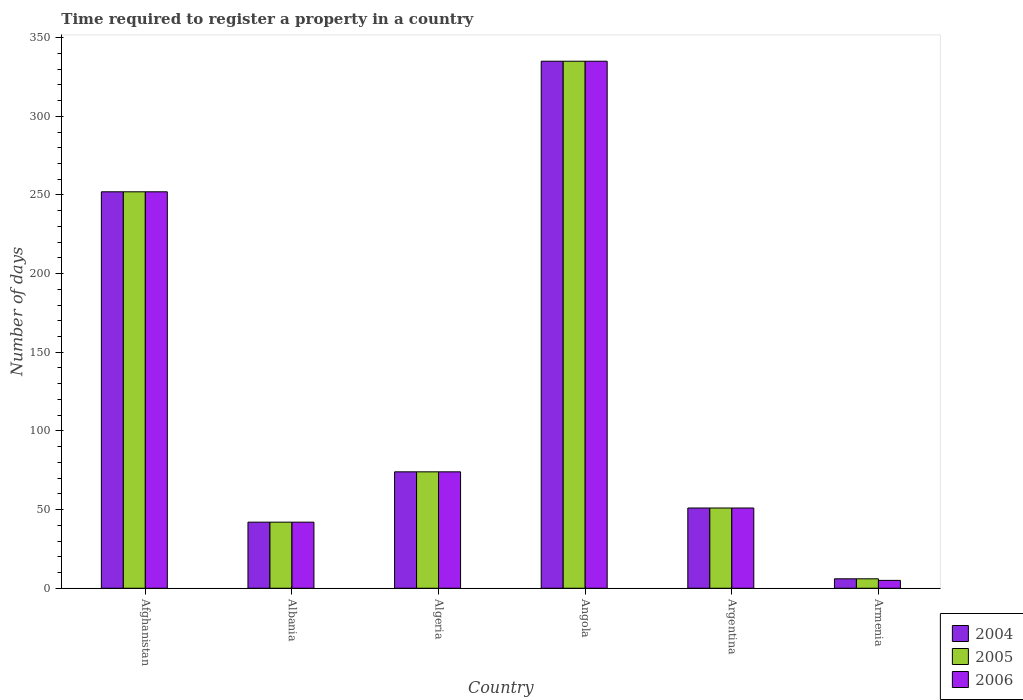Are the number of bars on each tick of the X-axis equal?
Provide a succinct answer. Yes. What is the label of the 3rd group of bars from the left?
Your response must be concise. Algeria. In how many cases, is the number of bars for a given country not equal to the number of legend labels?
Ensure brevity in your answer.  0. What is the number of days required to register a property in 2004 in Armenia?
Your answer should be compact. 6. Across all countries, what is the maximum number of days required to register a property in 2005?
Offer a terse response. 335. In which country was the number of days required to register a property in 2005 maximum?
Make the answer very short. Angola. In which country was the number of days required to register a property in 2004 minimum?
Your answer should be compact. Armenia. What is the total number of days required to register a property in 2006 in the graph?
Make the answer very short. 759. What is the difference between the number of days required to register a property in 2006 in Algeria and that in Angola?
Provide a succinct answer. -261. What is the difference between the number of days required to register a property in 2006 in Albania and the number of days required to register a property in 2004 in Angola?
Make the answer very short. -293. What is the average number of days required to register a property in 2006 per country?
Provide a succinct answer. 126.5. What is the difference between the number of days required to register a property of/in 2004 and number of days required to register a property of/in 2005 in Afghanistan?
Offer a terse response. 0. What is the ratio of the number of days required to register a property in 2004 in Angola to that in Argentina?
Keep it short and to the point. 6.57. Is the number of days required to register a property in 2006 in Afghanistan less than that in Albania?
Provide a succinct answer. No. Is the difference between the number of days required to register a property in 2004 in Afghanistan and Argentina greater than the difference between the number of days required to register a property in 2005 in Afghanistan and Argentina?
Keep it short and to the point. No. What is the difference between the highest and the second highest number of days required to register a property in 2006?
Provide a short and direct response. -178. What is the difference between the highest and the lowest number of days required to register a property in 2006?
Provide a succinct answer. 330. In how many countries, is the number of days required to register a property in 2006 greater than the average number of days required to register a property in 2006 taken over all countries?
Provide a short and direct response. 2. Is the sum of the number of days required to register a property in 2004 in Albania and Angola greater than the maximum number of days required to register a property in 2006 across all countries?
Make the answer very short. Yes. Is it the case that in every country, the sum of the number of days required to register a property in 2005 and number of days required to register a property in 2004 is greater than the number of days required to register a property in 2006?
Offer a very short reply. Yes. Are all the bars in the graph horizontal?
Your answer should be compact. No. How many countries are there in the graph?
Keep it short and to the point. 6. What is the difference between two consecutive major ticks on the Y-axis?
Your response must be concise. 50. Does the graph contain any zero values?
Provide a short and direct response. No. What is the title of the graph?
Provide a short and direct response. Time required to register a property in a country. Does "2008" appear as one of the legend labels in the graph?
Your answer should be very brief. No. What is the label or title of the Y-axis?
Offer a very short reply. Number of days. What is the Number of days in 2004 in Afghanistan?
Give a very brief answer. 252. What is the Number of days in 2005 in Afghanistan?
Make the answer very short. 252. What is the Number of days of 2006 in Afghanistan?
Make the answer very short. 252. What is the Number of days in 2005 in Albania?
Provide a succinct answer. 42. What is the Number of days in 2005 in Algeria?
Your response must be concise. 74. What is the Number of days in 2004 in Angola?
Offer a very short reply. 335. What is the Number of days of 2005 in Angola?
Your answer should be compact. 335. What is the Number of days in 2006 in Angola?
Give a very brief answer. 335. What is the Number of days in 2004 in Argentina?
Your response must be concise. 51. What is the Number of days in 2006 in Argentina?
Offer a very short reply. 51. What is the Number of days in 2004 in Armenia?
Offer a terse response. 6. What is the Number of days of 2006 in Armenia?
Keep it short and to the point. 5. Across all countries, what is the maximum Number of days of 2004?
Offer a very short reply. 335. Across all countries, what is the maximum Number of days of 2005?
Give a very brief answer. 335. Across all countries, what is the maximum Number of days in 2006?
Your response must be concise. 335. Across all countries, what is the minimum Number of days in 2004?
Offer a very short reply. 6. Across all countries, what is the minimum Number of days of 2006?
Keep it short and to the point. 5. What is the total Number of days of 2004 in the graph?
Your answer should be very brief. 760. What is the total Number of days of 2005 in the graph?
Provide a succinct answer. 760. What is the total Number of days of 2006 in the graph?
Provide a succinct answer. 759. What is the difference between the Number of days in 2004 in Afghanistan and that in Albania?
Ensure brevity in your answer.  210. What is the difference between the Number of days of 2005 in Afghanistan and that in Albania?
Make the answer very short. 210. What is the difference between the Number of days of 2006 in Afghanistan and that in Albania?
Give a very brief answer. 210. What is the difference between the Number of days in 2004 in Afghanistan and that in Algeria?
Give a very brief answer. 178. What is the difference between the Number of days of 2005 in Afghanistan and that in Algeria?
Provide a short and direct response. 178. What is the difference between the Number of days in 2006 in Afghanistan and that in Algeria?
Your answer should be compact. 178. What is the difference between the Number of days of 2004 in Afghanistan and that in Angola?
Give a very brief answer. -83. What is the difference between the Number of days of 2005 in Afghanistan and that in Angola?
Your answer should be very brief. -83. What is the difference between the Number of days in 2006 in Afghanistan and that in Angola?
Keep it short and to the point. -83. What is the difference between the Number of days of 2004 in Afghanistan and that in Argentina?
Your answer should be compact. 201. What is the difference between the Number of days of 2005 in Afghanistan and that in Argentina?
Make the answer very short. 201. What is the difference between the Number of days of 2006 in Afghanistan and that in Argentina?
Your answer should be very brief. 201. What is the difference between the Number of days of 2004 in Afghanistan and that in Armenia?
Your answer should be very brief. 246. What is the difference between the Number of days in 2005 in Afghanistan and that in Armenia?
Make the answer very short. 246. What is the difference between the Number of days of 2006 in Afghanistan and that in Armenia?
Your answer should be very brief. 247. What is the difference between the Number of days of 2004 in Albania and that in Algeria?
Your answer should be compact. -32. What is the difference between the Number of days of 2005 in Albania and that in Algeria?
Ensure brevity in your answer.  -32. What is the difference between the Number of days of 2006 in Albania and that in Algeria?
Your response must be concise. -32. What is the difference between the Number of days in 2004 in Albania and that in Angola?
Ensure brevity in your answer.  -293. What is the difference between the Number of days in 2005 in Albania and that in Angola?
Give a very brief answer. -293. What is the difference between the Number of days in 2006 in Albania and that in Angola?
Make the answer very short. -293. What is the difference between the Number of days in 2004 in Albania and that in Argentina?
Make the answer very short. -9. What is the difference between the Number of days in 2005 in Albania and that in Argentina?
Offer a very short reply. -9. What is the difference between the Number of days in 2005 in Albania and that in Armenia?
Provide a short and direct response. 36. What is the difference between the Number of days of 2006 in Albania and that in Armenia?
Give a very brief answer. 37. What is the difference between the Number of days of 2004 in Algeria and that in Angola?
Provide a short and direct response. -261. What is the difference between the Number of days in 2005 in Algeria and that in Angola?
Ensure brevity in your answer.  -261. What is the difference between the Number of days of 2006 in Algeria and that in Angola?
Ensure brevity in your answer.  -261. What is the difference between the Number of days of 2004 in Algeria and that in Argentina?
Keep it short and to the point. 23. What is the difference between the Number of days of 2006 in Algeria and that in Argentina?
Provide a short and direct response. 23. What is the difference between the Number of days in 2006 in Algeria and that in Armenia?
Ensure brevity in your answer.  69. What is the difference between the Number of days of 2004 in Angola and that in Argentina?
Your answer should be very brief. 284. What is the difference between the Number of days of 2005 in Angola and that in Argentina?
Your response must be concise. 284. What is the difference between the Number of days in 2006 in Angola and that in Argentina?
Make the answer very short. 284. What is the difference between the Number of days of 2004 in Angola and that in Armenia?
Your answer should be compact. 329. What is the difference between the Number of days of 2005 in Angola and that in Armenia?
Your answer should be compact. 329. What is the difference between the Number of days of 2006 in Angola and that in Armenia?
Offer a terse response. 330. What is the difference between the Number of days of 2006 in Argentina and that in Armenia?
Your response must be concise. 46. What is the difference between the Number of days of 2004 in Afghanistan and the Number of days of 2005 in Albania?
Offer a terse response. 210. What is the difference between the Number of days of 2004 in Afghanistan and the Number of days of 2006 in Albania?
Your response must be concise. 210. What is the difference between the Number of days of 2005 in Afghanistan and the Number of days of 2006 in Albania?
Your response must be concise. 210. What is the difference between the Number of days in 2004 in Afghanistan and the Number of days in 2005 in Algeria?
Your answer should be compact. 178. What is the difference between the Number of days of 2004 in Afghanistan and the Number of days of 2006 in Algeria?
Your response must be concise. 178. What is the difference between the Number of days in 2005 in Afghanistan and the Number of days in 2006 in Algeria?
Your answer should be very brief. 178. What is the difference between the Number of days in 2004 in Afghanistan and the Number of days in 2005 in Angola?
Keep it short and to the point. -83. What is the difference between the Number of days of 2004 in Afghanistan and the Number of days of 2006 in Angola?
Ensure brevity in your answer.  -83. What is the difference between the Number of days of 2005 in Afghanistan and the Number of days of 2006 in Angola?
Provide a succinct answer. -83. What is the difference between the Number of days in 2004 in Afghanistan and the Number of days in 2005 in Argentina?
Provide a succinct answer. 201. What is the difference between the Number of days in 2004 in Afghanistan and the Number of days in 2006 in Argentina?
Offer a very short reply. 201. What is the difference between the Number of days in 2005 in Afghanistan and the Number of days in 2006 in Argentina?
Offer a terse response. 201. What is the difference between the Number of days of 2004 in Afghanistan and the Number of days of 2005 in Armenia?
Your response must be concise. 246. What is the difference between the Number of days in 2004 in Afghanistan and the Number of days in 2006 in Armenia?
Provide a succinct answer. 247. What is the difference between the Number of days of 2005 in Afghanistan and the Number of days of 2006 in Armenia?
Keep it short and to the point. 247. What is the difference between the Number of days of 2004 in Albania and the Number of days of 2005 in Algeria?
Give a very brief answer. -32. What is the difference between the Number of days in 2004 in Albania and the Number of days in 2006 in Algeria?
Make the answer very short. -32. What is the difference between the Number of days in 2005 in Albania and the Number of days in 2006 in Algeria?
Your response must be concise. -32. What is the difference between the Number of days in 2004 in Albania and the Number of days in 2005 in Angola?
Give a very brief answer. -293. What is the difference between the Number of days in 2004 in Albania and the Number of days in 2006 in Angola?
Your answer should be very brief. -293. What is the difference between the Number of days in 2005 in Albania and the Number of days in 2006 in Angola?
Make the answer very short. -293. What is the difference between the Number of days in 2004 in Albania and the Number of days in 2005 in Argentina?
Offer a very short reply. -9. What is the difference between the Number of days in 2004 in Albania and the Number of days in 2005 in Armenia?
Your answer should be very brief. 36. What is the difference between the Number of days in 2005 in Albania and the Number of days in 2006 in Armenia?
Offer a terse response. 37. What is the difference between the Number of days in 2004 in Algeria and the Number of days in 2005 in Angola?
Make the answer very short. -261. What is the difference between the Number of days in 2004 in Algeria and the Number of days in 2006 in Angola?
Provide a succinct answer. -261. What is the difference between the Number of days in 2005 in Algeria and the Number of days in 2006 in Angola?
Give a very brief answer. -261. What is the difference between the Number of days in 2004 in Algeria and the Number of days in 2005 in Argentina?
Give a very brief answer. 23. What is the difference between the Number of days in 2004 in Algeria and the Number of days in 2006 in Argentina?
Offer a terse response. 23. What is the difference between the Number of days of 2004 in Algeria and the Number of days of 2005 in Armenia?
Ensure brevity in your answer.  68. What is the difference between the Number of days of 2005 in Algeria and the Number of days of 2006 in Armenia?
Your answer should be very brief. 69. What is the difference between the Number of days of 2004 in Angola and the Number of days of 2005 in Argentina?
Offer a very short reply. 284. What is the difference between the Number of days in 2004 in Angola and the Number of days in 2006 in Argentina?
Keep it short and to the point. 284. What is the difference between the Number of days in 2005 in Angola and the Number of days in 2006 in Argentina?
Your answer should be compact. 284. What is the difference between the Number of days in 2004 in Angola and the Number of days in 2005 in Armenia?
Ensure brevity in your answer.  329. What is the difference between the Number of days of 2004 in Angola and the Number of days of 2006 in Armenia?
Provide a short and direct response. 330. What is the difference between the Number of days in 2005 in Angola and the Number of days in 2006 in Armenia?
Keep it short and to the point. 330. What is the difference between the Number of days of 2005 in Argentina and the Number of days of 2006 in Armenia?
Offer a terse response. 46. What is the average Number of days in 2004 per country?
Make the answer very short. 126.67. What is the average Number of days in 2005 per country?
Offer a terse response. 126.67. What is the average Number of days in 2006 per country?
Keep it short and to the point. 126.5. What is the difference between the Number of days in 2004 and Number of days in 2005 in Afghanistan?
Keep it short and to the point. 0. What is the difference between the Number of days in 2004 and Number of days in 2006 in Afghanistan?
Offer a terse response. 0. What is the difference between the Number of days in 2005 and Number of days in 2006 in Albania?
Offer a very short reply. 0. What is the difference between the Number of days of 2004 and Number of days of 2006 in Algeria?
Provide a succinct answer. 0. What is the difference between the Number of days of 2005 and Number of days of 2006 in Algeria?
Offer a terse response. 0. What is the difference between the Number of days of 2005 and Number of days of 2006 in Angola?
Provide a short and direct response. 0. What is the difference between the Number of days in 2004 and Number of days in 2006 in Argentina?
Offer a terse response. 0. What is the difference between the Number of days in 2005 and Number of days in 2006 in Argentina?
Give a very brief answer. 0. What is the difference between the Number of days in 2004 and Number of days in 2006 in Armenia?
Ensure brevity in your answer.  1. What is the ratio of the Number of days in 2006 in Afghanistan to that in Albania?
Provide a succinct answer. 6. What is the ratio of the Number of days in 2004 in Afghanistan to that in Algeria?
Offer a terse response. 3.41. What is the ratio of the Number of days of 2005 in Afghanistan to that in Algeria?
Ensure brevity in your answer.  3.41. What is the ratio of the Number of days of 2006 in Afghanistan to that in Algeria?
Your answer should be very brief. 3.41. What is the ratio of the Number of days in 2004 in Afghanistan to that in Angola?
Provide a succinct answer. 0.75. What is the ratio of the Number of days in 2005 in Afghanistan to that in Angola?
Provide a short and direct response. 0.75. What is the ratio of the Number of days in 2006 in Afghanistan to that in Angola?
Give a very brief answer. 0.75. What is the ratio of the Number of days of 2004 in Afghanistan to that in Argentina?
Offer a very short reply. 4.94. What is the ratio of the Number of days in 2005 in Afghanistan to that in Argentina?
Make the answer very short. 4.94. What is the ratio of the Number of days in 2006 in Afghanistan to that in Argentina?
Keep it short and to the point. 4.94. What is the ratio of the Number of days in 2005 in Afghanistan to that in Armenia?
Provide a short and direct response. 42. What is the ratio of the Number of days of 2006 in Afghanistan to that in Armenia?
Provide a succinct answer. 50.4. What is the ratio of the Number of days in 2004 in Albania to that in Algeria?
Your answer should be compact. 0.57. What is the ratio of the Number of days of 2005 in Albania to that in Algeria?
Give a very brief answer. 0.57. What is the ratio of the Number of days in 2006 in Albania to that in Algeria?
Offer a terse response. 0.57. What is the ratio of the Number of days in 2004 in Albania to that in Angola?
Provide a succinct answer. 0.13. What is the ratio of the Number of days of 2005 in Albania to that in Angola?
Ensure brevity in your answer.  0.13. What is the ratio of the Number of days in 2006 in Albania to that in Angola?
Your answer should be compact. 0.13. What is the ratio of the Number of days in 2004 in Albania to that in Argentina?
Your answer should be very brief. 0.82. What is the ratio of the Number of days of 2005 in Albania to that in Argentina?
Your answer should be very brief. 0.82. What is the ratio of the Number of days of 2006 in Albania to that in Argentina?
Ensure brevity in your answer.  0.82. What is the ratio of the Number of days in 2004 in Albania to that in Armenia?
Ensure brevity in your answer.  7. What is the ratio of the Number of days in 2005 in Albania to that in Armenia?
Offer a very short reply. 7. What is the ratio of the Number of days of 2006 in Albania to that in Armenia?
Your response must be concise. 8.4. What is the ratio of the Number of days in 2004 in Algeria to that in Angola?
Offer a very short reply. 0.22. What is the ratio of the Number of days in 2005 in Algeria to that in Angola?
Your answer should be very brief. 0.22. What is the ratio of the Number of days of 2006 in Algeria to that in Angola?
Keep it short and to the point. 0.22. What is the ratio of the Number of days of 2004 in Algeria to that in Argentina?
Offer a terse response. 1.45. What is the ratio of the Number of days of 2005 in Algeria to that in Argentina?
Your answer should be compact. 1.45. What is the ratio of the Number of days of 2006 in Algeria to that in Argentina?
Your response must be concise. 1.45. What is the ratio of the Number of days of 2004 in Algeria to that in Armenia?
Keep it short and to the point. 12.33. What is the ratio of the Number of days in 2005 in Algeria to that in Armenia?
Give a very brief answer. 12.33. What is the ratio of the Number of days of 2006 in Algeria to that in Armenia?
Make the answer very short. 14.8. What is the ratio of the Number of days in 2004 in Angola to that in Argentina?
Your response must be concise. 6.57. What is the ratio of the Number of days in 2005 in Angola to that in Argentina?
Make the answer very short. 6.57. What is the ratio of the Number of days of 2006 in Angola to that in Argentina?
Your answer should be very brief. 6.57. What is the ratio of the Number of days in 2004 in Angola to that in Armenia?
Provide a short and direct response. 55.83. What is the ratio of the Number of days of 2005 in Angola to that in Armenia?
Ensure brevity in your answer.  55.83. What is the ratio of the Number of days of 2006 in Angola to that in Armenia?
Make the answer very short. 67. What is the ratio of the Number of days in 2004 in Argentina to that in Armenia?
Ensure brevity in your answer.  8.5. What is the ratio of the Number of days of 2005 in Argentina to that in Armenia?
Your answer should be compact. 8.5. What is the difference between the highest and the second highest Number of days in 2006?
Make the answer very short. 83. What is the difference between the highest and the lowest Number of days in 2004?
Offer a terse response. 329. What is the difference between the highest and the lowest Number of days of 2005?
Ensure brevity in your answer.  329. What is the difference between the highest and the lowest Number of days in 2006?
Give a very brief answer. 330. 